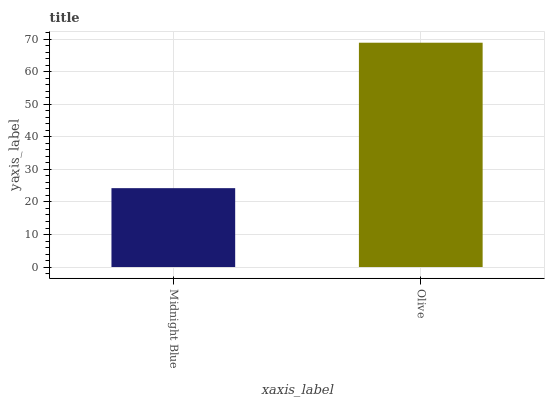Is Midnight Blue the minimum?
Answer yes or no. Yes. Is Olive the maximum?
Answer yes or no. Yes. Is Olive the minimum?
Answer yes or no. No. Is Olive greater than Midnight Blue?
Answer yes or no. Yes. Is Midnight Blue less than Olive?
Answer yes or no. Yes. Is Midnight Blue greater than Olive?
Answer yes or no. No. Is Olive less than Midnight Blue?
Answer yes or no. No. Is Olive the high median?
Answer yes or no. Yes. Is Midnight Blue the low median?
Answer yes or no. Yes. Is Midnight Blue the high median?
Answer yes or no. No. Is Olive the low median?
Answer yes or no. No. 